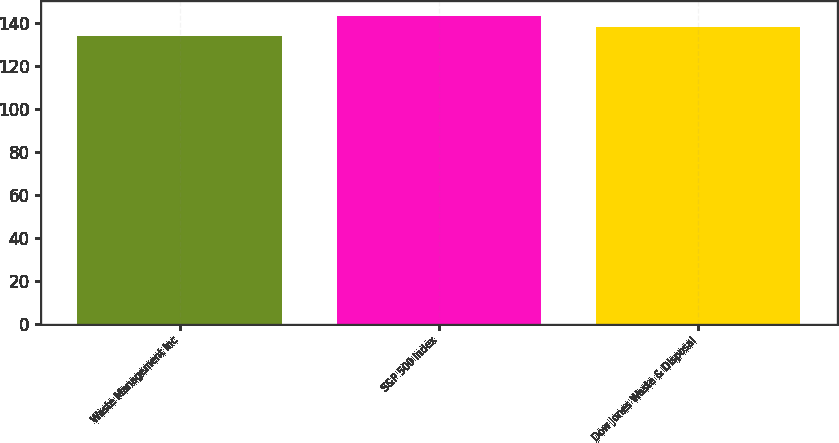<chart> <loc_0><loc_0><loc_500><loc_500><bar_chart><fcel>Waste Management Inc<fcel>S&P 500 Index<fcel>Dow Jones Waste & Disposal<nl><fcel>134<fcel>143<fcel>138<nl></chart> 